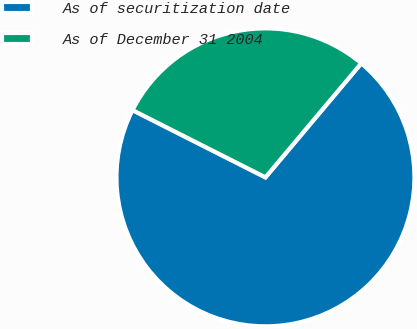Convert chart. <chart><loc_0><loc_0><loc_500><loc_500><pie_chart><fcel>As of securitization date<fcel>As of December 31 2004<nl><fcel>71.33%<fcel>28.67%<nl></chart> 